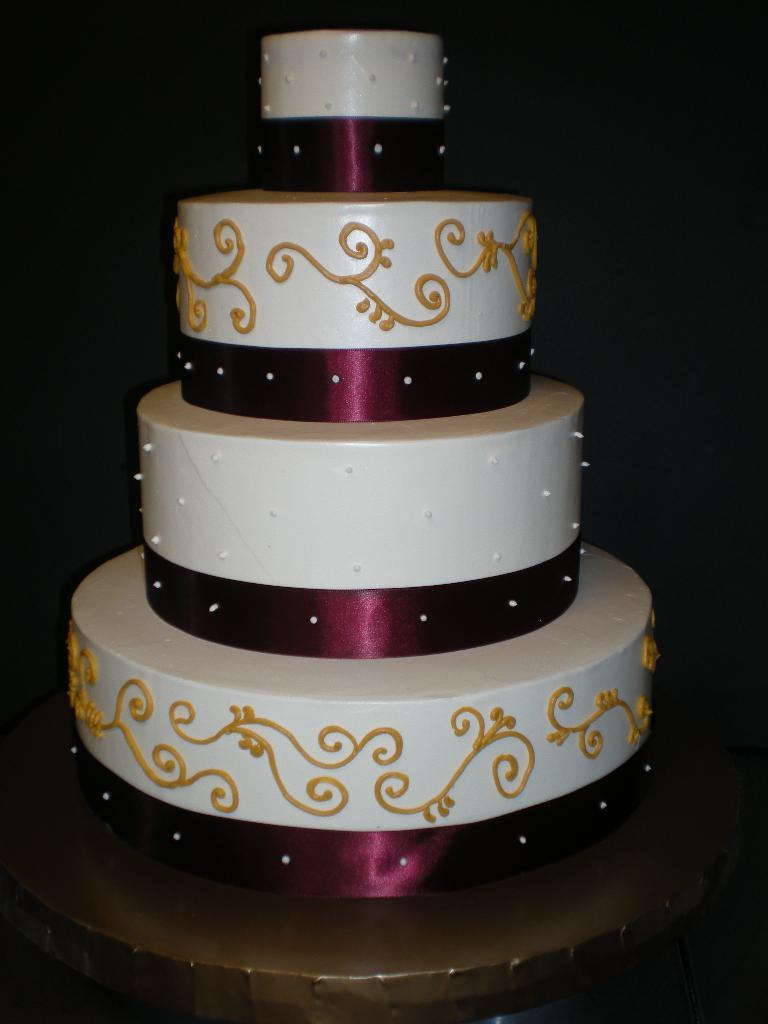What is the main subject of the image? The main subject of the image is a cake. What decoration can be seen on the cake? There is a violet-colored ribbon on the cake. What is the color of the background in the image? The background of the image is dark. What thought is the cake having in the image? Cakes do not have thoughts, as they are inanimate objects. How much time has passed since the cake was baked in the image? The image does not provide any information about when the cake was baked or how much time has passed since then. 